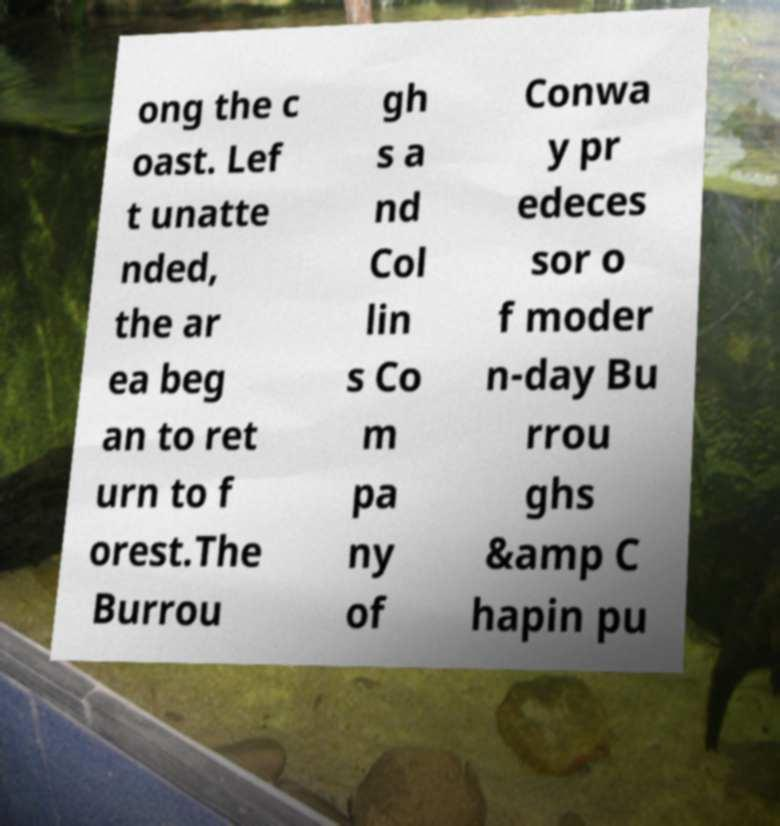For documentation purposes, I need the text within this image transcribed. Could you provide that? ong the c oast. Lef t unatte nded, the ar ea beg an to ret urn to f orest.The Burrou gh s a nd Col lin s Co m pa ny of Conwa y pr edeces sor o f moder n-day Bu rrou ghs &amp C hapin pu 